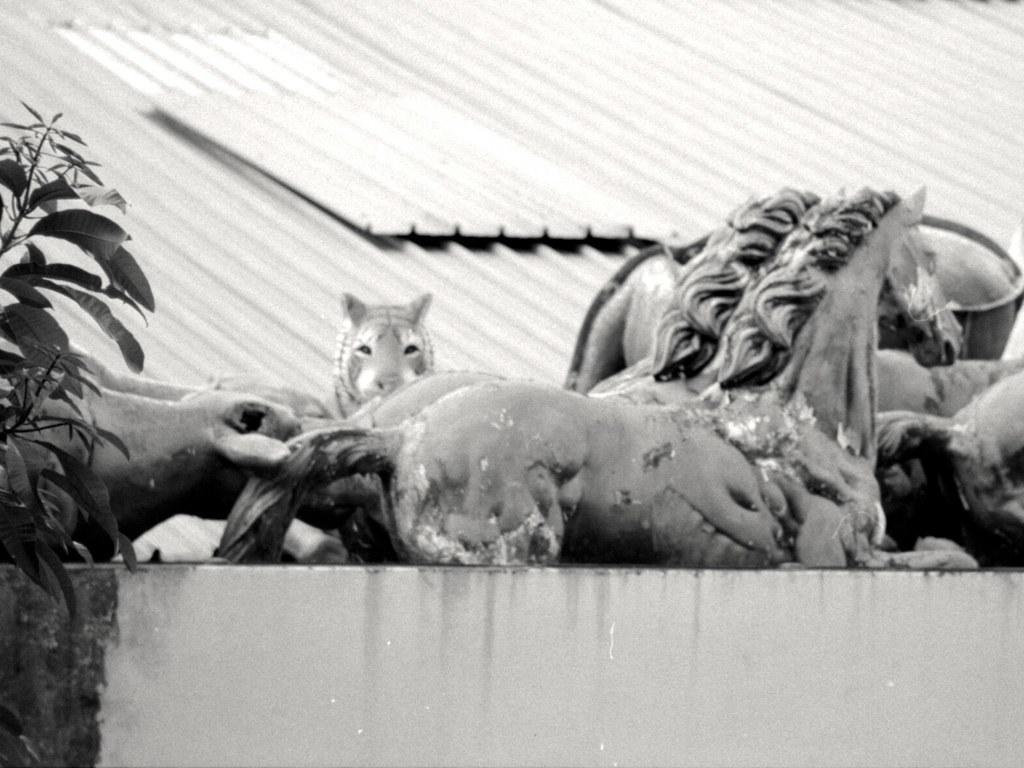Describe this image in one or two sentences. In this picture we can see statues of animals on the platform. On the left side of the image we can see leaves and stems. In the background of the image we can see sheets. 